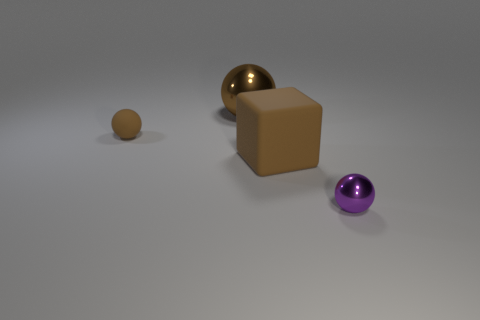What number of other objects are there of the same material as the tiny purple ball?
Make the answer very short. 1. There is a small object that is behind the small purple metal thing; does it have the same shape as the large brown shiny thing?
Offer a terse response. Yes. How many big objects are either brown metal things or brown cubes?
Keep it short and to the point. 2. Are there the same number of tiny brown things that are on the right side of the brown shiny ball and metallic spheres behind the big matte cube?
Give a very brief answer. No. How many other things are there of the same color as the large rubber block?
Make the answer very short. 2. There is a tiny matte ball; is its color the same as the large matte thing on the right side of the small matte thing?
Ensure brevity in your answer.  Yes. What number of brown things are either large matte things or big metal spheres?
Make the answer very short. 2. Is the number of brown shiny objects that are behind the big brown ball the same as the number of small matte balls?
Provide a succinct answer. No. What is the color of the tiny metal object that is the same shape as the small rubber thing?
Provide a succinct answer. Purple. What number of brown metal objects have the same shape as the purple shiny object?
Offer a very short reply. 1. 